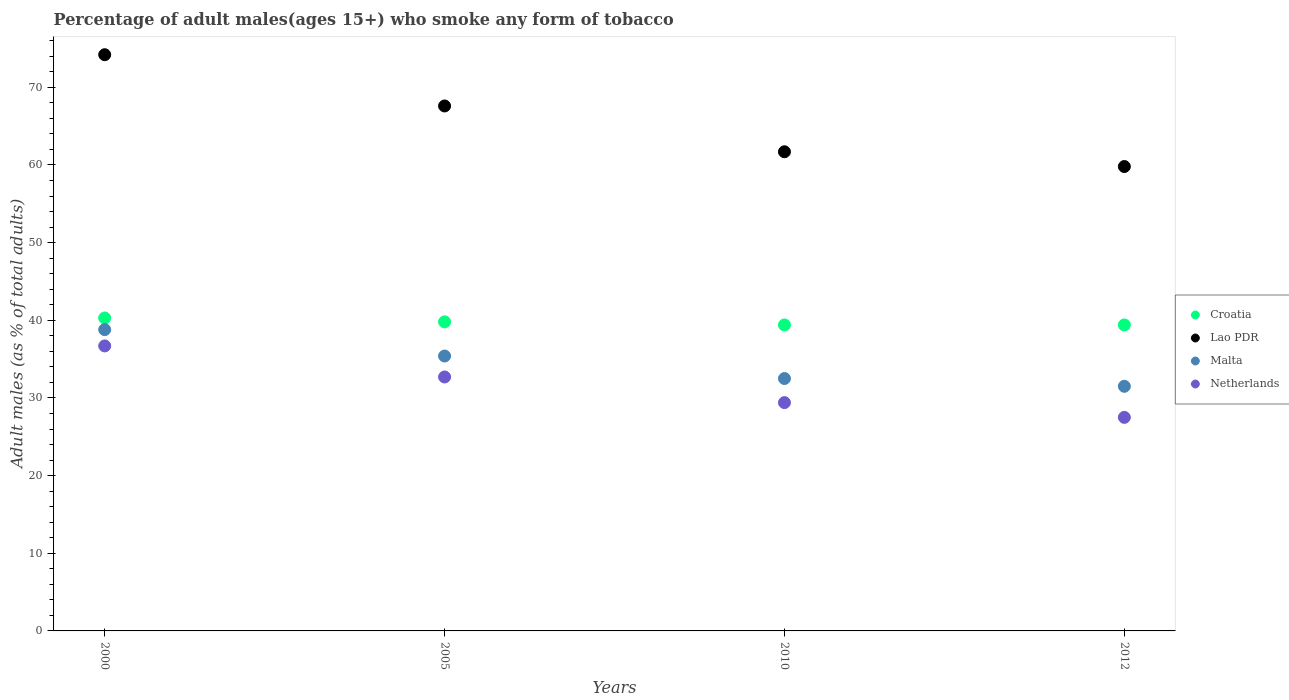How many different coloured dotlines are there?
Offer a very short reply. 4. Is the number of dotlines equal to the number of legend labels?
Keep it short and to the point. Yes. What is the percentage of adult males who smoke in Malta in 2000?
Provide a succinct answer. 38.8. Across all years, what is the maximum percentage of adult males who smoke in Malta?
Your response must be concise. 38.8. Across all years, what is the minimum percentage of adult males who smoke in Netherlands?
Your response must be concise. 27.5. In which year was the percentage of adult males who smoke in Lao PDR maximum?
Keep it short and to the point. 2000. What is the total percentage of adult males who smoke in Malta in the graph?
Your response must be concise. 138.2. What is the difference between the percentage of adult males who smoke in Netherlands in 2000 and that in 2005?
Your answer should be compact. 4. What is the difference between the percentage of adult males who smoke in Lao PDR in 2012 and the percentage of adult males who smoke in Netherlands in 2010?
Your answer should be very brief. 30.4. What is the average percentage of adult males who smoke in Netherlands per year?
Keep it short and to the point. 31.58. In the year 2005, what is the difference between the percentage of adult males who smoke in Malta and percentage of adult males who smoke in Croatia?
Give a very brief answer. -4.4. What is the ratio of the percentage of adult males who smoke in Lao PDR in 2000 to that in 2012?
Offer a very short reply. 1.24. Is the percentage of adult males who smoke in Lao PDR in 2000 less than that in 2005?
Ensure brevity in your answer.  No. Is the difference between the percentage of adult males who smoke in Malta in 2010 and 2012 greater than the difference between the percentage of adult males who smoke in Croatia in 2010 and 2012?
Provide a succinct answer. Yes. What is the difference between the highest and the second highest percentage of adult males who smoke in Malta?
Make the answer very short. 3.4. What is the difference between the highest and the lowest percentage of adult males who smoke in Netherlands?
Your answer should be very brief. 9.2. Is the sum of the percentage of adult males who smoke in Lao PDR in 2000 and 2010 greater than the maximum percentage of adult males who smoke in Croatia across all years?
Your answer should be very brief. Yes. Is it the case that in every year, the sum of the percentage of adult males who smoke in Lao PDR and percentage of adult males who smoke in Netherlands  is greater than the sum of percentage of adult males who smoke in Croatia and percentage of adult males who smoke in Malta?
Keep it short and to the point. Yes. Is it the case that in every year, the sum of the percentage of adult males who smoke in Malta and percentage of adult males who smoke in Netherlands  is greater than the percentage of adult males who smoke in Croatia?
Ensure brevity in your answer.  Yes. Is the percentage of adult males who smoke in Netherlands strictly greater than the percentage of adult males who smoke in Croatia over the years?
Your response must be concise. No. Is the percentage of adult males who smoke in Lao PDR strictly less than the percentage of adult males who smoke in Malta over the years?
Keep it short and to the point. No. How many years are there in the graph?
Your answer should be compact. 4. What is the difference between two consecutive major ticks on the Y-axis?
Ensure brevity in your answer.  10. Are the values on the major ticks of Y-axis written in scientific E-notation?
Make the answer very short. No. Does the graph contain any zero values?
Your answer should be very brief. No. Where does the legend appear in the graph?
Provide a succinct answer. Center right. How many legend labels are there?
Keep it short and to the point. 4. How are the legend labels stacked?
Offer a very short reply. Vertical. What is the title of the graph?
Give a very brief answer. Percentage of adult males(ages 15+) who smoke any form of tobacco. Does "Jordan" appear as one of the legend labels in the graph?
Make the answer very short. No. What is the label or title of the Y-axis?
Offer a terse response. Adult males (as % of total adults). What is the Adult males (as % of total adults) of Croatia in 2000?
Ensure brevity in your answer.  40.3. What is the Adult males (as % of total adults) of Lao PDR in 2000?
Offer a very short reply. 74.2. What is the Adult males (as % of total adults) in Malta in 2000?
Give a very brief answer. 38.8. What is the Adult males (as % of total adults) in Netherlands in 2000?
Provide a succinct answer. 36.7. What is the Adult males (as % of total adults) in Croatia in 2005?
Provide a succinct answer. 39.8. What is the Adult males (as % of total adults) of Lao PDR in 2005?
Keep it short and to the point. 67.6. What is the Adult males (as % of total adults) in Malta in 2005?
Give a very brief answer. 35.4. What is the Adult males (as % of total adults) in Netherlands in 2005?
Keep it short and to the point. 32.7. What is the Adult males (as % of total adults) in Croatia in 2010?
Your answer should be very brief. 39.4. What is the Adult males (as % of total adults) of Lao PDR in 2010?
Make the answer very short. 61.7. What is the Adult males (as % of total adults) of Malta in 2010?
Ensure brevity in your answer.  32.5. What is the Adult males (as % of total adults) in Netherlands in 2010?
Offer a very short reply. 29.4. What is the Adult males (as % of total adults) of Croatia in 2012?
Offer a very short reply. 39.4. What is the Adult males (as % of total adults) in Lao PDR in 2012?
Provide a succinct answer. 59.8. What is the Adult males (as % of total adults) in Malta in 2012?
Offer a very short reply. 31.5. Across all years, what is the maximum Adult males (as % of total adults) of Croatia?
Provide a succinct answer. 40.3. Across all years, what is the maximum Adult males (as % of total adults) in Lao PDR?
Your answer should be compact. 74.2. Across all years, what is the maximum Adult males (as % of total adults) of Malta?
Give a very brief answer. 38.8. Across all years, what is the maximum Adult males (as % of total adults) of Netherlands?
Offer a terse response. 36.7. Across all years, what is the minimum Adult males (as % of total adults) in Croatia?
Your response must be concise. 39.4. Across all years, what is the minimum Adult males (as % of total adults) of Lao PDR?
Provide a short and direct response. 59.8. Across all years, what is the minimum Adult males (as % of total adults) in Malta?
Give a very brief answer. 31.5. What is the total Adult males (as % of total adults) in Croatia in the graph?
Keep it short and to the point. 158.9. What is the total Adult males (as % of total adults) of Lao PDR in the graph?
Provide a succinct answer. 263.3. What is the total Adult males (as % of total adults) of Malta in the graph?
Your answer should be very brief. 138.2. What is the total Adult males (as % of total adults) in Netherlands in the graph?
Make the answer very short. 126.3. What is the difference between the Adult males (as % of total adults) of Croatia in 2000 and that in 2005?
Offer a terse response. 0.5. What is the difference between the Adult males (as % of total adults) of Lao PDR in 2000 and that in 2010?
Your answer should be compact. 12.5. What is the difference between the Adult males (as % of total adults) in Malta in 2000 and that in 2010?
Keep it short and to the point. 6.3. What is the difference between the Adult males (as % of total adults) of Croatia in 2000 and that in 2012?
Provide a succinct answer. 0.9. What is the difference between the Adult males (as % of total adults) of Malta in 2000 and that in 2012?
Your answer should be compact. 7.3. What is the difference between the Adult males (as % of total adults) of Netherlands in 2005 and that in 2010?
Provide a short and direct response. 3.3. What is the difference between the Adult males (as % of total adults) of Croatia in 2005 and that in 2012?
Keep it short and to the point. 0.4. What is the difference between the Adult males (as % of total adults) in Lao PDR in 2010 and that in 2012?
Keep it short and to the point. 1.9. What is the difference between the Adult males (as % of total adults) of Croatia in 2000 and the Adult males (as % of total adults) of Lao PDR in 2005?
Your answer should be compact. -27.3. What is the difference between the Adult males (as % of total adults) in Croatia in 2000 and the Adult males (as % of total adults) in Malta in 2005?
Your answer should be very brief. 4.9. What is the difference between the Adult males (as % of total adults) of Lao PDR in 2000 and the Adult males (as % of total adults) of Malta in 2005?
Provide a short and direct response. 38.8. What is the difference between the Adult males (as % of total adults) in Lao PDR in 2000 and the Adult males (as % of total adults) in Netherlands in 2005?
Your answer should be compact. 41.5. What is the difference between the Adult males (as % of total adults) in Croatia in 2000 and the Adult males (as % of total adults) in Lao PDR in 2010?
Ensure brevity in your answer.  -21.4. What is the difference between the Adult males (as % of total adults) of Croatia in 2000 and the Adult males (as % of total adults) of Malta in 2010?
Give a very brief answer. 7.8. What is the difference between the Adult males (as % of total adults) of Croatia in 2000 and the Adult males (as % of total adults) of Netherlands in 2010?
Provide a short and direct response. 10.9. What is the difference between the Adult males (as % of total adults) in Lao PDR in 2000 and the Adult males (as % of total adults) in Malta in 2010?
Offer a terse response. 41.7. What is the difference between the Adult males (as % of total adults) of Lao PDR in 2000 and the Adult males (as % of total adults) of Netherlands in 2010?
Offer a very short reply. 44.8. What is the difference between the Adult males (as % of total adults) of Croatia in 2000 and the Adult males (as % of total adults) of Lao PDR in 2012?
Give a very brief answer. -19.5. What is the difference between the Adult males (as % of total adults) in Croatia in 2000 and the Adult males (as % of total adults) in Malta in 2012?
Provide a succinct answer. 8.8. What is the difference between the Adult males (as % of total adults) of Lao PDR in 2000 and the Adult males (as % of total adults) of Malta in 2012?
Your response must be concise. 42.7. What is the difference between the Adult males (as % of total adults) of Lao PDR in 2000 and the Adult males (as % of total adults) of Netherlands in 2012?
Provide a succinct answer. 46.7. What is the difference between the Adult males (as % of total adults) in Malta in 2000 and the Adult males (as % of total adults) in Netherlands in 2012?
Offer a very short reply. 11.3. What is the difference between the Adult males (as % of total adults) in Croatia in 2005 and the Adult males (as % of total adults) in Lao PDR in 2010?
Keep it short and to the point. -21.9. What is the difference between the Adult males (as % of total adults) of Croatia in 2005 and the Adult males (as % of total adults) of Malta in 2010?
Make the answer very short. 7.3. What is the difference between the Adult males (as % of total adults) in Lao PDR in 2005 and the Adult males (as % of total adults) in Malta in 2010?
Keep it short and to the point. 35.1. What is the difference between the Adult males (as % of total adults) in Lao PDR in 2005 and the Adult males (as % of total adults) in Netherlands in 2010?
Give a very brief answer. 38.2. What is the difference between the Adult males (as % of total adults) of Malta in 2005 and the Adult males (as % of total adults) of Netherlands in 2010?
Offer a terse response. 6. What is the difference between the Adult males (as % of total adults) in Croatia in 2005 and the Adult males (as % of total adults) in Netherlands in 2012?
Make the answer very short. 12.3. What is the difference between the Adult males (as % of total adults) in Lao PDR in 2005 and the Adult males (as % of total adults) in Malta in 2012?
Provide a short and direct response. 36.1. What is the difference between the Adult males (as % of total adults) in Lao PDR in 2005 and the Adult males (as % of total adults) in Netherlands in 2012?
Offer a terse response. 40.1. What is the difference between the Adult males (as % of total adults) in Malta in 2005 and the Adult males (as % of total adults) in Netherlands in 2012?
Your answer should be very brief. 7.9. What is the difference between the Adult males (as % of total adults) in Croatia in 2010 and the Adult males (as % of total adults) in Lao PDR in 2012?
Your answer should be compact. -20.4. What is the difference between the Adult males (as % of total adults) of Croatia in 2010 and the Adult males (as % of total adults) of Malta in 2012?
Your response must be concise. 7.9. What is the difference between the Adult males (as % of total adults) in Croatia in 2010 and the Adult males (as % of total adults) in Netherlands in 2012?
Provide a short and direct response. 11.9. What is the difference between the Adult males (as % of total adults) in Lao PDR in 2010 and the Adult males (as % of total adults) in Malta in 2012?
Keep it short and to the point. 30.2. What is the difference between the Adult males (as % of total adults) in Lao PDR in 2010 and the Adult males (as % of total adults) in Netherlands in 2012?
Your answer should be very brief. 34.2. What is the average Adult males (as % of total adults) in Croatia per year?
Make the answer very short. 39.73. What is the average Adult males (as % of total adults) of Lao PDR per year?
Your response must be concise. 65.83. What is the average Adult males (as % of total adults) in Malta per year?
Your answer should be compact. 34.55. What is the average Adult males (as % of total adults) in Netherlands per year?
Ensure brevity in your answer.  31.57. In the year 2000, what is the difference between the Adult males (as % of total adults) of Croatia and Adult males (as % of total adults) of Lao PDR?
Your answer should be compact. -33.9. In the year 2000, what is the difference between the Adult males (as % of total adults) in Lao PDR and Adult males (as % of total adults) in Malta?
Your answer should be very brief. 35.4. In the year 2000, what is the difference between the Adult males (as % of total adults) in Lao PDR and Adult males (as % of total adults) in Netherlands?
Provide a short and direct response. 37.5. In the year 2005, what is the difference between the Adult males (as % of total adults) in Croatia and Adult males (as % of total adults) in Lao PDR?
Provide a short and direct response. -27.8. In the year 2005, what is the difference between the Adult males (as % of total adults) in Croatia and Adult males (as % of total adults) in Netherlands?
Offer a terse response. 7.1. In the year 2005, what is the difference between the Adult males (as % of total adults) in Lao PDR and Adult males (as % of total adults) in Malta?
Ensure brevity in your answer.  32.2. In the year 2005, what is the difference between the Adult males (as % of total adults) of Lao PDR and Adult males (as % of total adults) of Netherlands?
Offer a terse response. 34.9. In the year 2005, what is the difference between the Adult males (as % of total adults) in Malta and Adult males (as % of total adults) in Netherlands?
Give a very brief answer. 2.7. In the year 2010, what is the difference between the Adult males (as % of total adults) in Croatia and Adult males (as % of total adults) in Lao PDR?
Offer a terse response. -22.3. In the year 2010, what is the difference between the Adult males (as % of total adults) of Lao PDR and Adult males (as % of total adults) of Malta?
Offer a terse response. 29.2. In the year 2010, what is the difference between the Adult males (as % of total adults) in Lao PDR and Adult males (as % of total adults) in Netherlands?
Your response must be concise. 32.3. In the year 2012, what is the difference between the Adult males (as % of total adults) of Croatia and Adult males (as % of total adults) of Lao PDR?
Give a very brief answer. -20.4. In the year 2012, what is the difference between the Adult males (as % of total adults) of Lao PDR and Adult males (as % of total adults) of Malta?
Your response must be concise. 28.3. In the year 2012, what is the difference between the Adult males (as % of total adults) in Lao PDR and Adult males (as % of total adults) in Netherlands?
Offer a terse response. 32.3. What is the ratio of the Adult males (as % of total adults) of Croatia in 2000 to that in 2005?
Ensure brevity in your answer.  1.01. What is the ratio of the Adult males (as % of total adults) in Lao PDR in 2000 to that in 2005?
Keep it short and to the point. 1.1. What is the ratio of the Adult males (as % of total adults) in Malta in 2000 to that in 2005?
Provide a succinct answer. 1.1. What is the ratio of the Adult males (as % of total adults) in Netherlands in 2000 to that in 2005?
Offer a very short reply. 1.12. What is the ratio of the Adult males (as % of total adults) of Croatia in 2000 to that in 2010?
Offer a very short reply. 1.02. What is the ratio of the Adult males (as % of total adults) in Lao PDR in 2000 to that in 2010?
Offer a terse response. 1.2. What is the ratio of the Adult males (as % of total adults) in Malta in 2000 to that in 2010?
Ensure brevity in your answer.  1.19. What is the ratio of the Adult males (as % of total adults) of Netherlands in 2000 to that in 2010?
Provide a short and direct response. 1.25. What is the ratio of the Adult males (as % of total adults) of Croatia in 2000 to that in 2012?
Offer a terse response. 1.02. What is the ratio of the Adult males (as % of total adults) of Lao PDR in 2000 to that in 2012?
Your response must be concise. 1.24. What is the ratio of the Adult males (as % of total adults) in Malta in 2000 to that in 2012?
Ensure brevity in your answer.  1.23. What is the ratio of the Adult males (as % of total adults) of Netherlands in 2000 to that in 2012?
Offer a terse response. 1.33. What is the ratio of the Adult males (as % of total adults) in Croatia in 2005 to that in 2010?
Provide a succinct answer. 1.01. What is the ratio of the Adult males (as % of total adults) of Lao PDR in 2005 to that in 2010?
Keep it short and to the point. 1.1. What is the ratio of the Adult males (as % of total adults) in Malta in 2005 to that in 2010?
Offer a terse response. 1.09. What is the ratio of the Adult males (as % of total adults) of Netherlands in 2005 to that in 2010?
Make the answer very short. 1.11. What is the ratio of the Adult males (as % of total adults) in Croatia in 2005 to that in 2012?
Your answer should be compact. 1.01. What is the ratio of the Adult males (as % of total adults) in Lao PDR in 2005 to that in 2012?
Offer a terse response. 1.13. What is the ratio of the Adult males (as % of total adults) in Malta in 2005 to that in 2012?
Keep it short and to the point. 1.12. What is the ratio of the Adult males (as % of total adults) of Netherlands in 2005 to that in 2012?
Give a very brief answer. 1.19. What is the ratio of the Adult males (as % of total adults) in Croatia in 2010 to that in 2012?
Offer a very short reply. 1. What is the ratio of the Adult males (as % of total adults) in Lao PDR in 2010 to that in 2012?
Provide a short and direct response. 1.03. What is the ratio of the Adult males (as % of total adults) of Malta in 2010 to that in 2012?
Keep it short and to the point. 1.03. What is the ratio of the Adult males (as % of total adults) in Netherlands in 2010 to that in 2012?
Keep it short and to the point. 1.07. What is the difference between the highest and the second highest Adult males (as % of total adults) of Netherlands?
Provide a short and direct response. 4. What is the difference between the highest and the lowest Adult males (as % of total adults) in Croatia?
Make the answer very short. 0.9. What is the difference between the highest and the lowest Adult males (as % of total adults) of Lao PDR?
Make the answer very short. 14.4. What is the difference between the highest and the lowest Adult males (as % of total adults) in Malta?
Give a very brief answer. 7.3. 